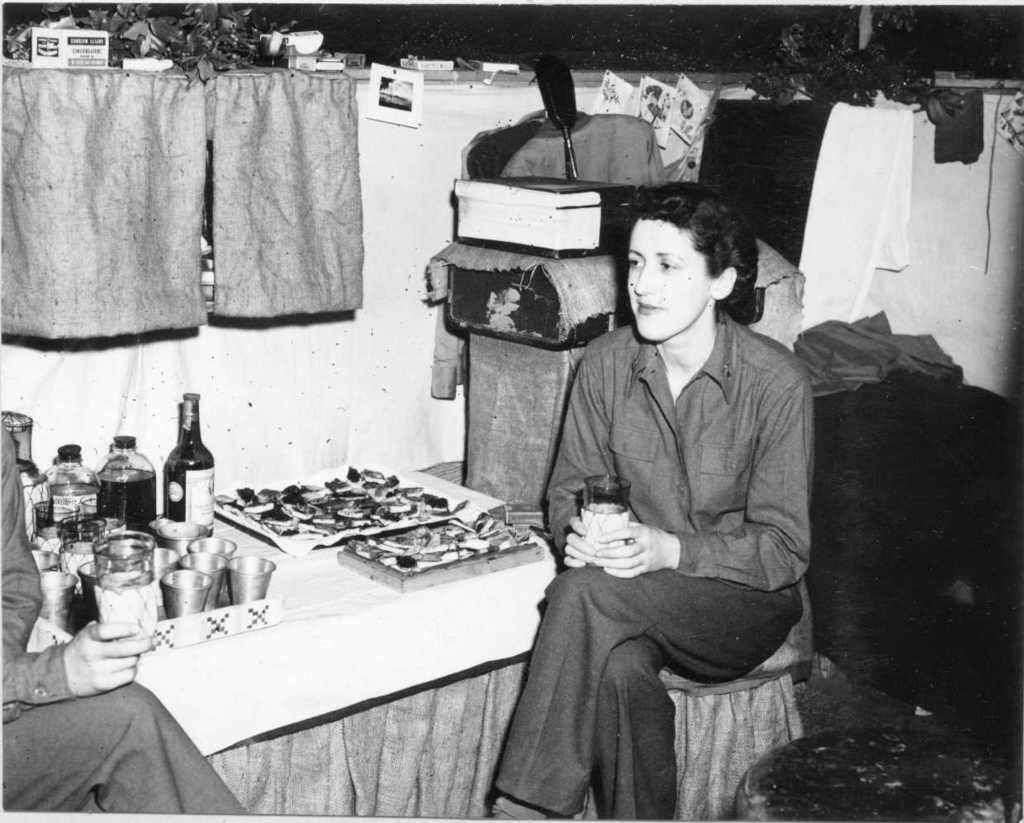In one or two sentences, can you explain what this image depicts? In the picture we can see an old photograph of a woman sitting near the table and in front of her we can see another person sitting holding a glass and on the table, we can see some bottles, glass in the tray and beside the table, we can see the wall with two curtains and beside it we can see some things like bags, luggage and some clothes. 